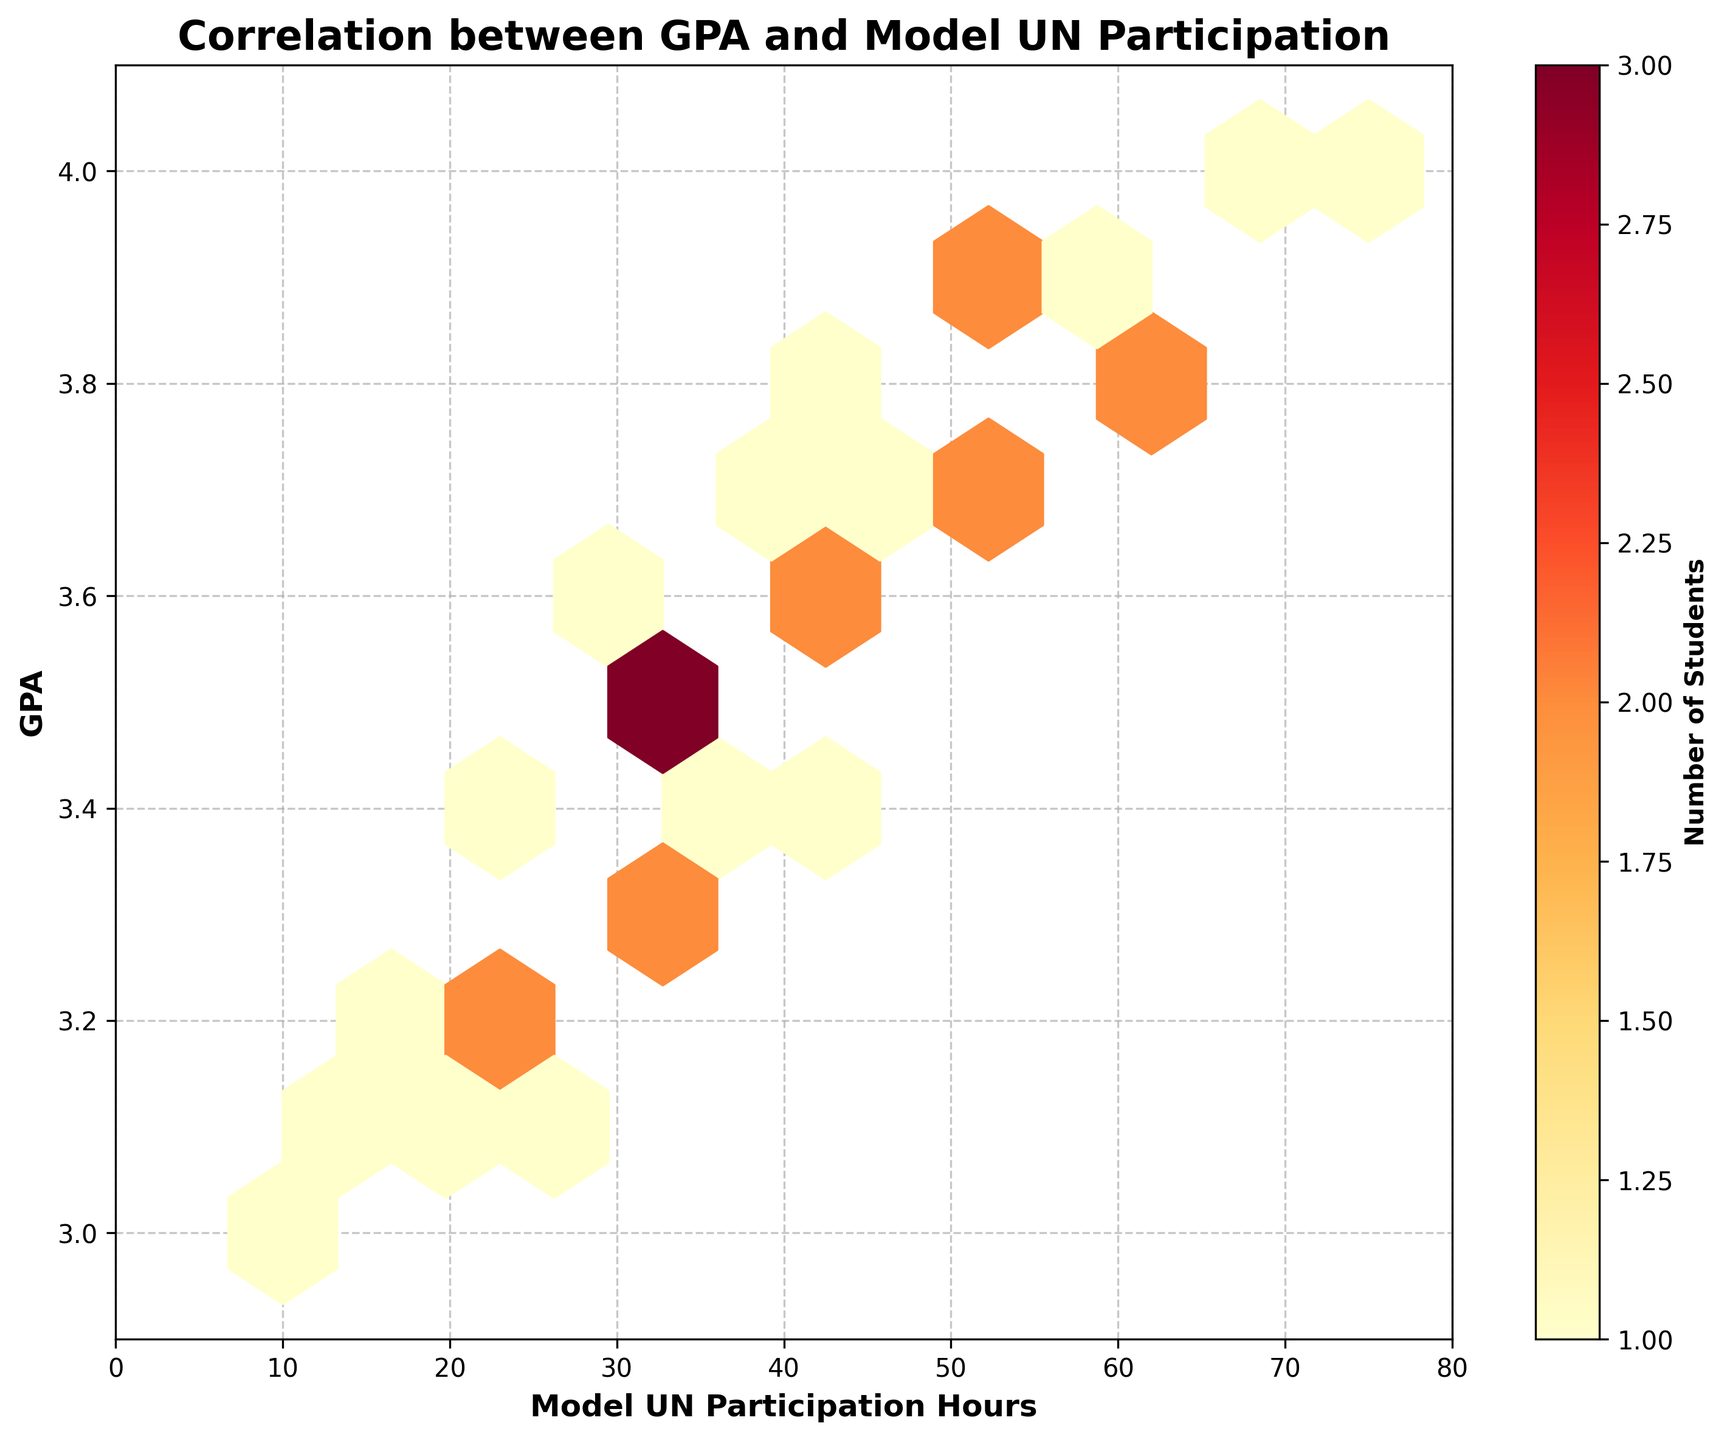How many data points are most densely clustered in the plot? Look at the color bar to understand the density. The most densely clustered points are represented by the brightest color in the hexbin plot.
Answer: 4 What does the color gradient represent in the plot? The color gradient, from light yellow to dark red, represents the number of students within each hexbin. Brighter colors indicate more students.
Answer: Number of students What trend do you observe between GPA and Model UN participation hours? Observe the overall pattern of the hexbin plot. It appears that there is a positive correlation as higher GPA values tend to cluster with higher participation hours.
Answer: Positive correlation What is the range of Model UN participation hours shown in the plot? Look at the x-axis, which represents Model UN participation hours, to determine the range.
Answer: 0 to 80 hours Among students with 50-60 hours of MUN participation, what can be said about their GPA distribution? Focus on hexagons at 50-60 hours on the x-axis and observe where they are spread on the y-axis. Most data points in this range tend to cluster around GPA values of 3.7 to 4.0.
Answer: GPA is generally between 3.7 and 4.0 Which range of MUN participation hours appears to have the most diverse GPA distribution? Look for a wider spread of hexagons vertically within specific x-axis ranges. The hours between 20 to 40 appear to have a more diverse GPA distribution from around 3.1 to 3.7.
Answer: 20 to 40 hours Are there any students with a GPA of 4.0 and low MUN participation hours? Inspect the hexbin cells near the GPA value of 4.0 on the y-axis with lower values on the x-axis. There are no data points with low participation hours and a GPA of 4.0.
Answer: No What does the title of the plot indicate about the study? The plot title, "Correlation between GPA and Model UN Participation," suggests that the purpose of the study is to analyze the relationship between students' academic performance and their involvement in Model UN activities.
Answer: Relationship analysis Do you observe any outliers in the plot? Look for hexagons that are isolated or far from the general cluster of data points. There are no significant outliers visible in terms of GPA values and participation hours.
Answer: No significant outliers What is the average GPA for students with MUN participation hours greater than 50? Locate hexagons to the right of 50 on the x-axis and identify their y-axis values. Most of these points tend to have GPA values around 3.7 to 4.0, averaging around 3.85.
Answer: Approximately 3.85 